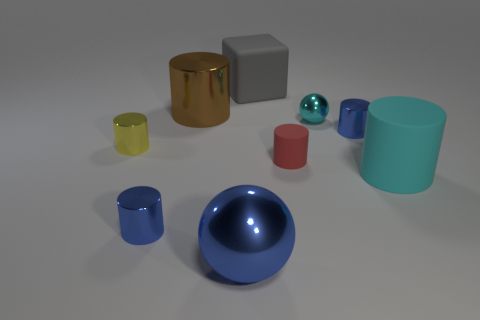What textures can be identified among the different objects in the scene? In this scene, the textures vary among the objects. The grey block and the teal cylinder have a matte, rubber-like texture. The blue and cyan spheres, as well as the gold and yellow cylinders, exhibit a glossy, reflective surface that implies a smoother texture. Do these textures make any of the objects appear more realistic than others? Yes, the objects with reflective surfaces, such as the spheres and the gold cylinder, tend to appear more realistic because they interact with the light in the scene, creating highlights and reflections that mimic real-world materials. 